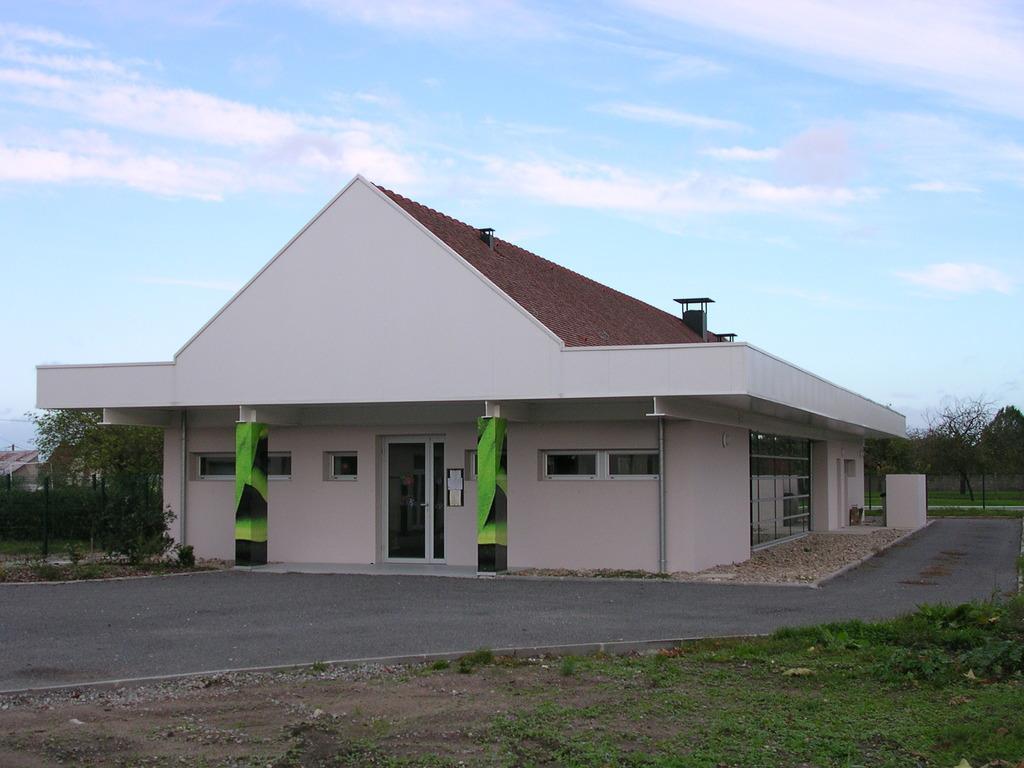What type of structures can be seen in the image? There are buildings in the image. What type of vegetation is present in the image? There are trees in the image. What covers the ground in the image? There is grass on the ground in the image. How would you describe the sky in the image? The sky is blue and cloudy in the image. What type of drink is being served during the recess in the image? There is no recess or drink present in the image; it features buildings, trees, grass, and a blue, cloudy sky. 